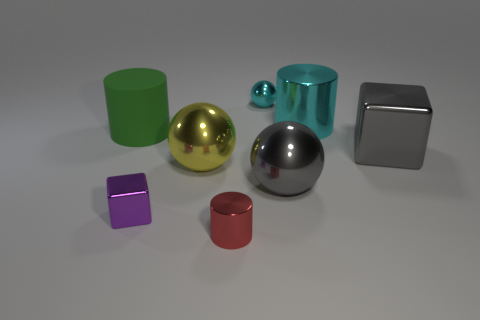Add 1 tiny red cylinders. How many objects exist? 9 Subtract all spheres. How many objects are left? 5 Subtract all tiny green metal balls. Subtract all gray metal objects. How many objects are left? 6 Add 6 metal blocks. How many metal blocks are left? 8 Add 4 shiny spheres. How many shiny spheres exist? 7 Subtract 0 blue cylinders. How many objects are left? 8 